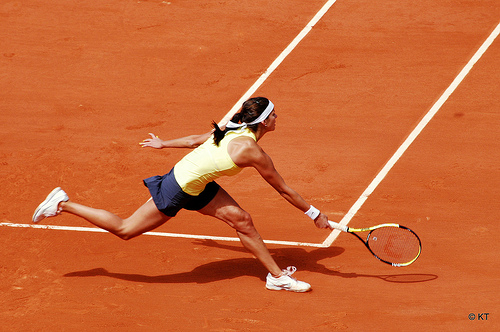The person to the left of the racket wears what? The person to the left is wearing a yellow shirt, suitable for the sport. 